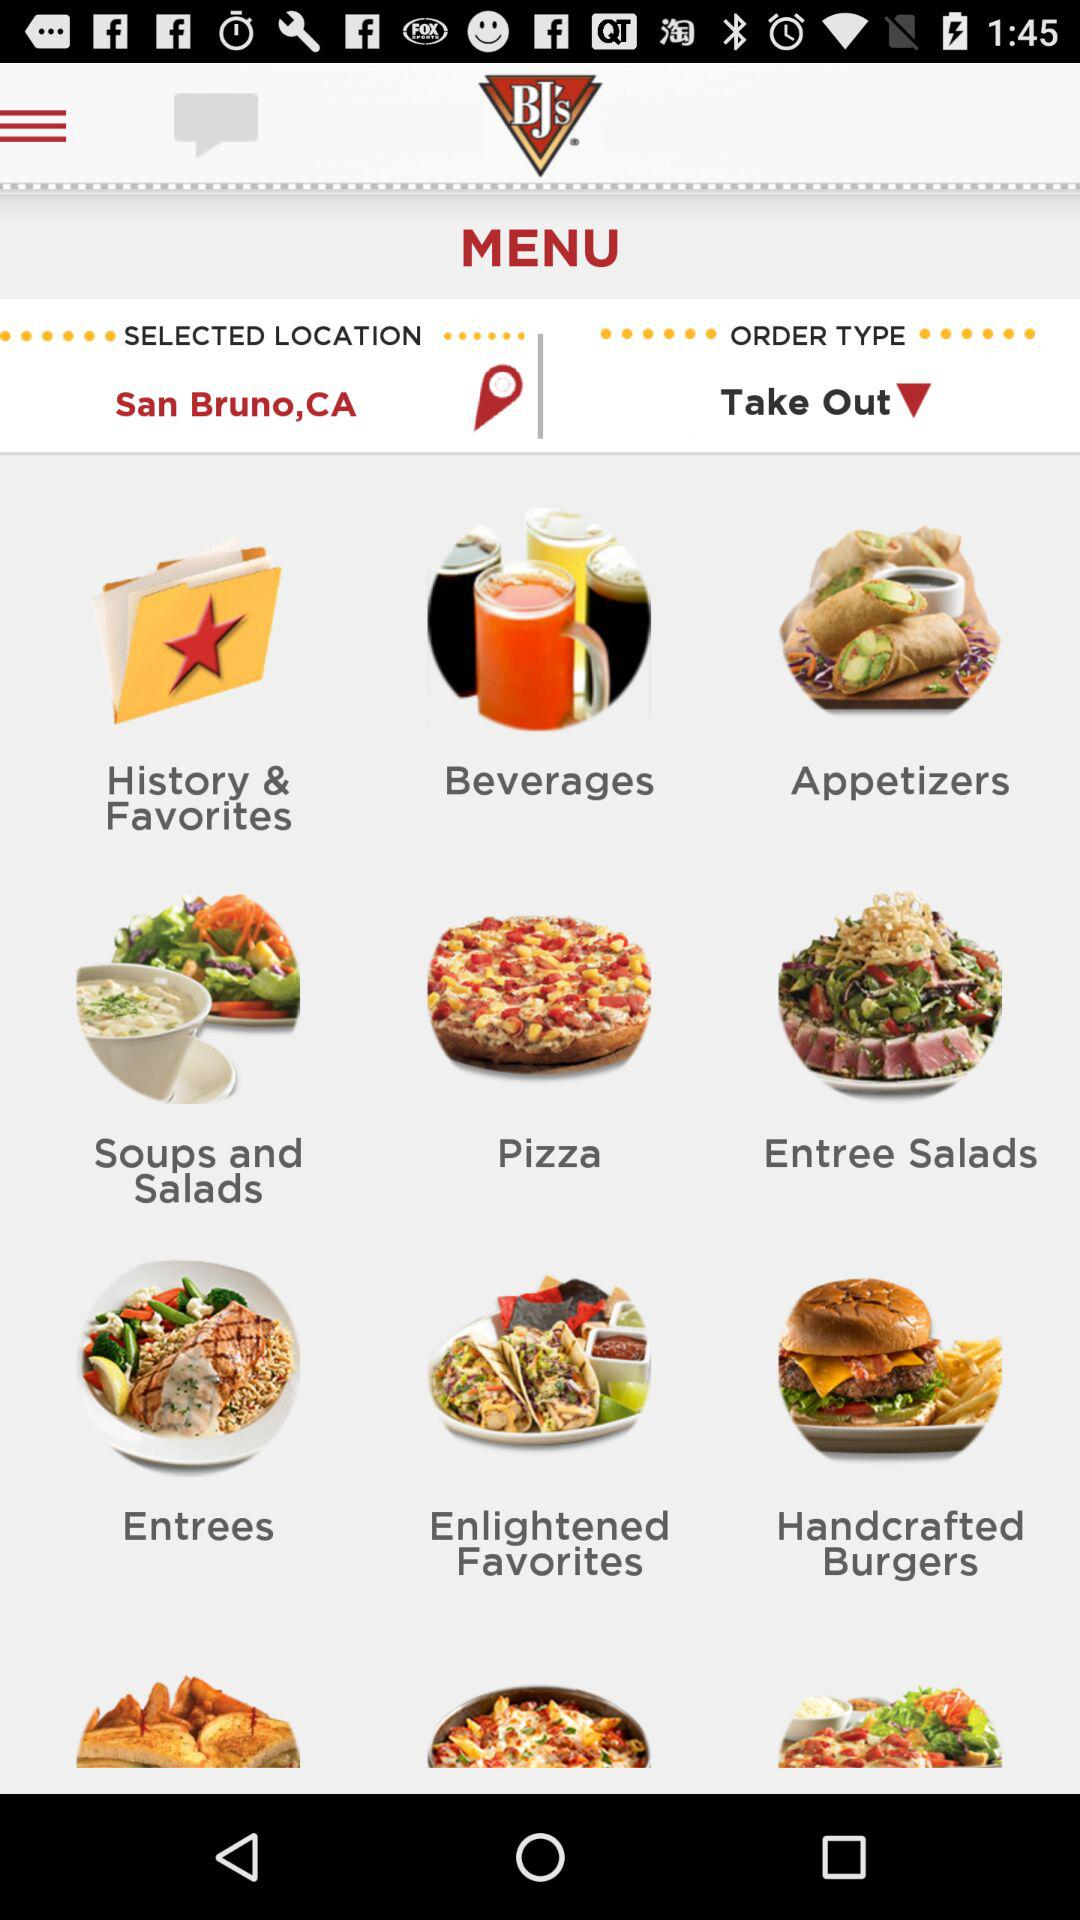What is the selected location? The selected location is San Bruno, CA. 